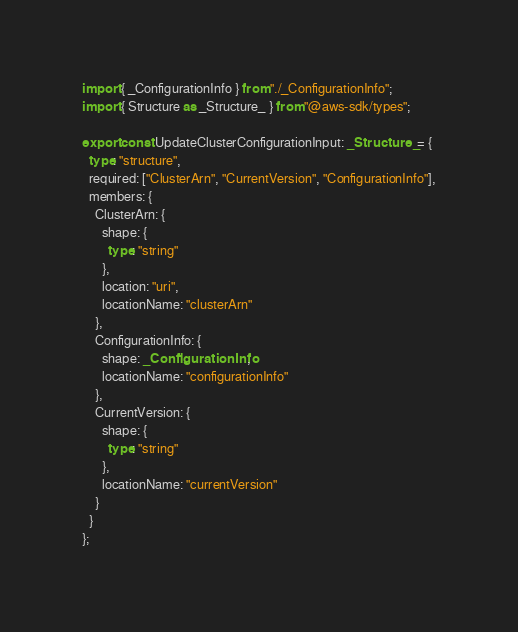<code> <loc_0><loc_0><loc_500><loc_500><_TypeScript_>import { _ConfigurationInfo } from "./_ConfigurationInfo";
import { Structure as _Structure_ } from "@aws-sdk/types";

export const UpdateClusterConfigurationInput: _Structure_ = {
  type: "structure",
  required: ["ClusterArn", "CurrentVersion", "ConfigurationInfo"],
  members: {
    ClusterArn: {
      shape: {
        type: "string"
      },
      location: "uri",
      locationName: "clusterArn"
    },
    ConfigurationInfo: {
      shape: _ConfigurationInfo,
      locationName: "configurationInfo"
    },
    CurrentVersion: {
      shape: {
        type: "string"
      },
      locationName: "currentVersion"
    }
  }
};
</code> 